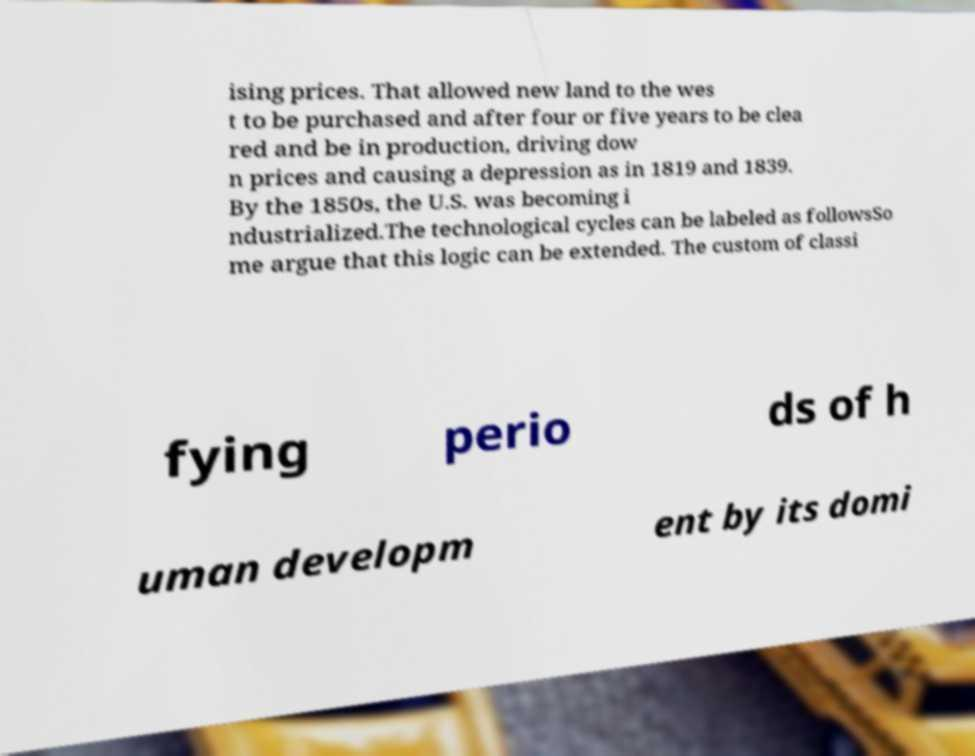Can you read and provide the text displayed in the image?This photo seems to have some interesting text. Can you extract and type it out for me? ising prices. That allowed new land to the wes t to be purchased and after four or five years to be clea red and be in production, driving dow n prices and causing a depression as in 1819 and 1839. By the 1850s, the U.S. was becoming i ndustrialized.The technological cycles can be labeled as followsSo me argue that this logic can be extended. The custom of classi fying perio ds of h uman developm ent by its domi 